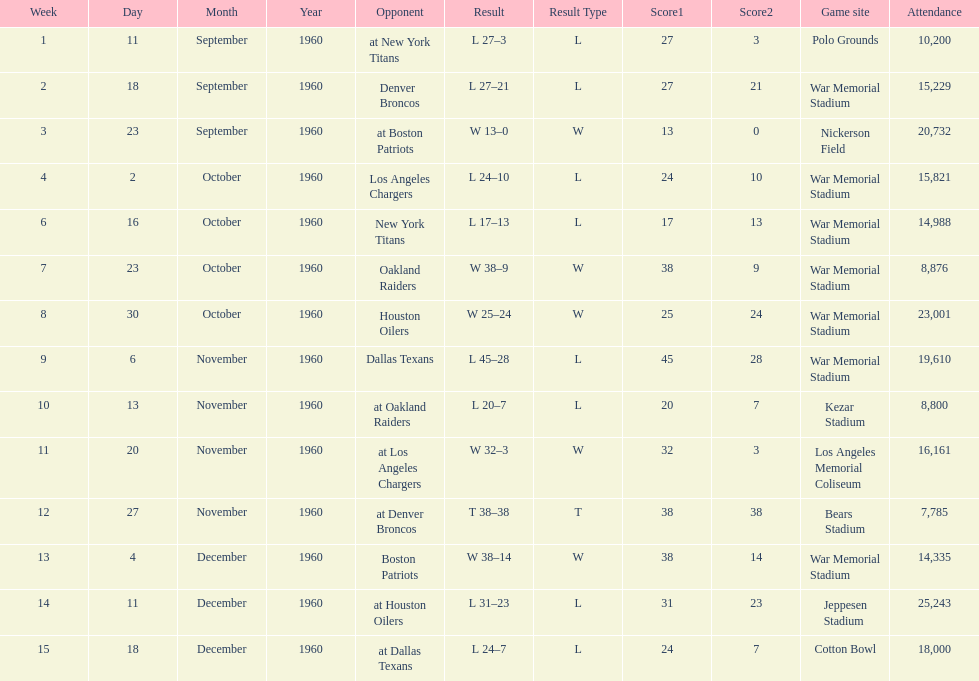How many games had at least 10,000 people in attendance? 11. I'm looking to parse the entire table for insights. Could you assist me with that? {'header': ['Week', 'Day', 'Month', 'Year', 'Opponent', 'Result', 'Result Type', 'Score1', 'Score2', 'Game site', 'Attendance'], 'rows': [['1', '11', 'September', '1960', 'at New York Titans', 'L 27–3', 'L', '27', '3', 'Polo Grounds', '10,200'], ['2', '18', 'September', '1960', 'Denver Broncos', 'L 27–21', 'L', '27', '21', 'War Memorial Stadium', '15,229'], ['3', '23', 'September', '1960', 'at Boston Patriots', 'W 13–0', 'W', '13', '0', 'Nickerson Field', '20,732'], ['4', '2', 'October', '1960', 'Los Angeles Chargers', 'L 24–10', 'L', '24', '10', 'War Memorial Stadium', '15,821'], ['6', '16', 'October', '1960', 'New York Titans', 'L 17–13', 'L', '17', '13', 'War Memorial Stadium', '14,988'], ['7', '23', 'October', '1960', 'Oakland Raiders', 'W 38–9', 'W', '38', '9', 'War Memorial Stadium', '8,876'], ['8', '30', 'October', '1960', 'Houston Oilers', 'W 25–24', 'W', '25', '24', 'War Memorial Stadium', '23,001'], ['9', '6', 'November', '1960', 'Dallas Texans', 'L 45–28', 'L', '45', '28', 'War Memorial Stadium', '19,610'], ['10', '13', 'November', '1960', 'at Oakland Raiders', 'L 20–7', 'L', '20', '7', 'Kezar Stadium', '8,800'], ['11', '20', 'November', '1960', 'at Los Angeles Chargers', 'W 32–3', 'W', '32', '3', 'Los Angeles Memorial Coliseum', '16,161'], ['12', '27', 'November', '1960', 'at Denver Broncos', 'T 38–38', 'T', '38', '38', 'Bears Stadium', '7,785'], ['13', '4', 'December', '1960', 'Boston Patriots', 'W 38–14', 'W', '38', '14', 'War Memorial Stadium', '14,335'], ['14', '11', 'December', '1960', 'at Houston Oilers', 'L 31–23', 'L', '31', '23', 'Jeppesen Stadium', '25,243'], ['15', '18', 'December', '1960', 'at Dallas Texans', 'L 24–7', 'L', '24', '7', 'Cotton Bowl', '18,000']]} 